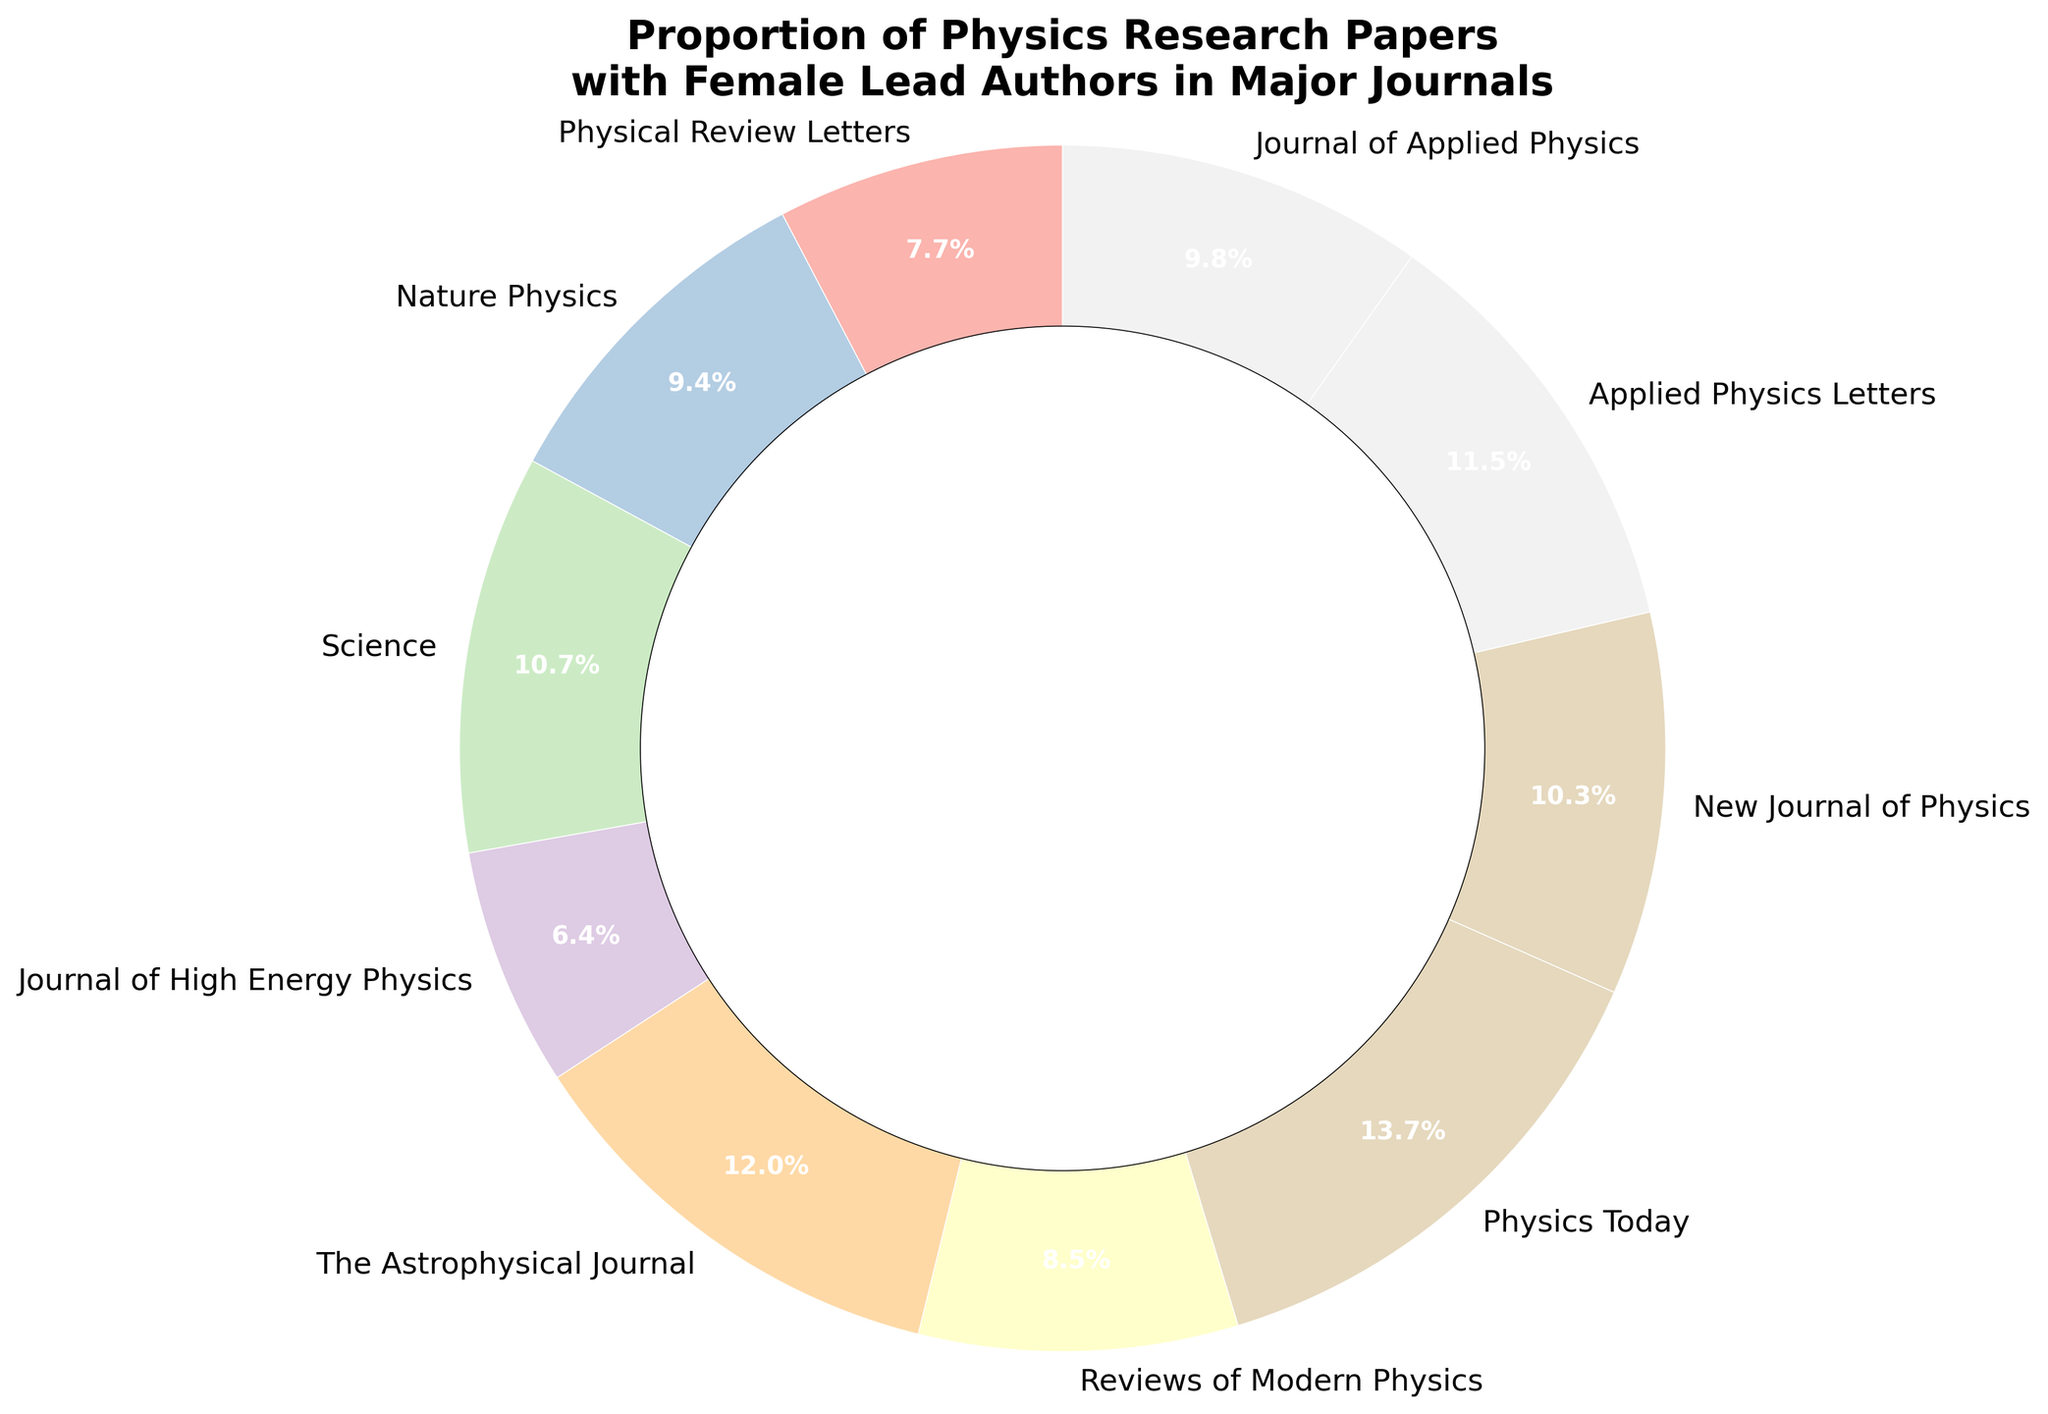What percentage of papers with female lead authors is reported in "Physics Today"? Locate the label "Physics Today" on the chart, which specifies 32%.
Answer: 32% Is the percentage of female lead authors in "Science" higher than in "Physical Review Letters"? Locate both labels "Science" and "Physical Review Letters". "Science" has 25% and "Physical Review Letters" has 18%. 25% > 18%, so yes.
Answer: Yes Which journal has the lowest percentage of female lead authors, and what is that percentage? Identify the wedge with the smallest percentage. "Journal of High Energy Physics" is the smallest at 15%.
Answer: Journal of High Energy Physics, 15% What's the combined percentage of female lead authors in "Journal of Applied Physics" and "Applied Physics Letters"? Locate both labels. "Journal of Applied Physics" has 23% and "Applied Physics Letters" has 27%. Sum these values: \( 23\% + 27\% = 50\% \).
Answer: 50% Which journal has the second-highest proportion of female lead authors? Identify the top two percentages and their corresponding labels. The highest is "Physics Today" at 32%, and the second highest is "The Astrophysical Journal" at 28%.
Answer: The Astrophysical Journal Do "Nature Physics" and "New Journal of Physics" together account for more than 40% of the female lead author papers? Add the percentages for "Nature Physics" (22%) and "New Journal of Physics" (24%), resulting in \(22\% + 24\% = 46\%\). 46% > 40%, so yes.
Answer: Yes Between "Physical Review Letters" and "Reviews of Modern Physics," which journal has a higher percentage of female lead authors and by how much? Locate both wedges. "Reviews of Modern Physics" has 20% and "Physical Review Letters" has 18%. Calculate the difference: \(20\% - 18\% = 2\%\).
Answer: Reviews of Modern Physics, 2% What's the average percentage of female lead authors across all the journals shown? Sum all percentages: \(18\% + 22\% + 25\% + 15\% + 28\% + 20\% + 32\% + 24\% + 27\% + 23\% = 234\%\). Divide by the number of journals (10): \(234\% / 10 = 23.4\%\).
Answer: 23.4% 